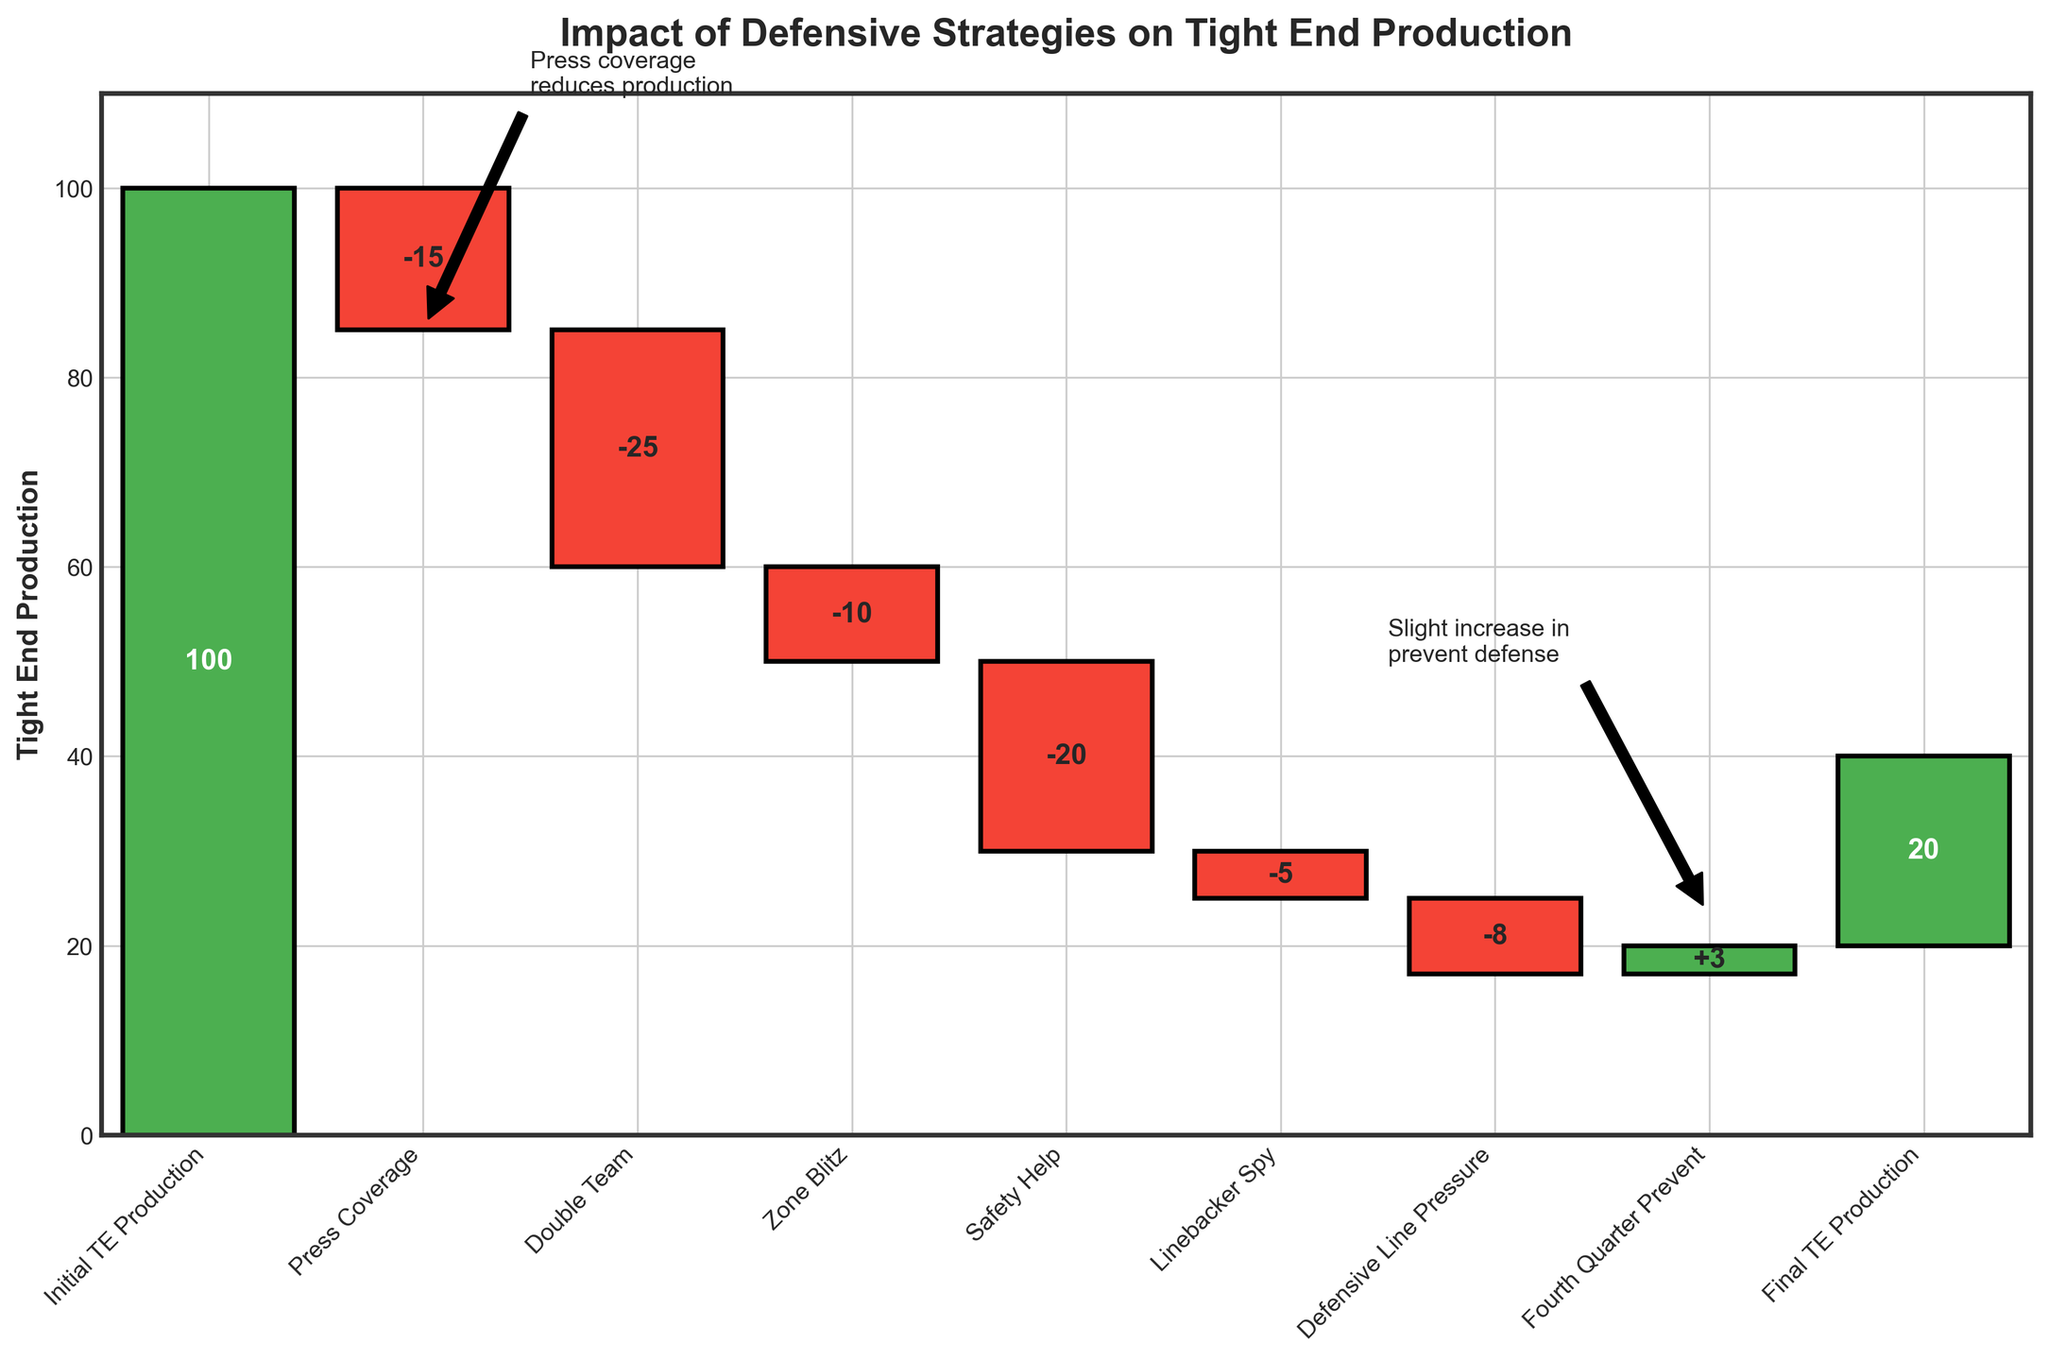What is the title of the waterfall chart? The title can be found at the top of the chart. It provides the main topic or purpose of the figure.
Answer: Impact of Defensive Strategies on Tight End Production What is the initial tight end production value? The initial tight end production value is the first value listed in the chart, usually at the starting point of the visualization. In this case, it's labeled as "Initial TE Production."
Answer: 100 How much did the strategy "Press Coverage" reduce the tight end production? Locate the "Press Coverage" bar and observe the value associated with it. The chart highlights it with a negative value, indicating a reduction.
Answer: -15 What is the cumulative impact on tight end production after implementing the "Press Coverage" and "Double Team" strategies? Calculate the sum of the impacts of "Press Coverage" and "Double Team." The values are -15 and -25, respectively. Adding them gives the cumulative impact.
Answer: -40 Which defensive strategy had the smallest negative impact on tight end production? Compare the negative impacts of all defensive strategies. The one with the smallest absolute value will be the answer.
Answer: Linebacker Spy Which defensive strategy showed a positive impact on tight end production, and what was the value? Look for the strategy that has a bar extending positively. The only positive value here is identified by the label "Fourth Quarter Prevent."
Answer: Fourth Quarter Prevent, +3 By how much did the strategy "Safety Help" reduce the tight end production? Identify the "Safety Help" bar and note its value. The chart shows this as a negative impact, reducing production by the value indicated.
Answer: -20 What was the final tight end production value after all strategies were applied? Find the final value labeled "Final TE Production" at the end of the waterfall chart.
Answer: 20 What is the total reduction in tight end production due to all defensive strategies applied before the "Fourth Quarter Prevent"? Sum the values of all negative impacts before the "Fourth Quarter Prevent" strategy. These include -15, -25, -10, -20, -5, and -8.
Answer: -83 What does the annotation near the "Press Coverage" strategy signify? Look at the annotation above the "Press Coverage" bar. It provides context or commentary related to the strategy's impact on tight end production.
Answer: Press coverage reduces production 